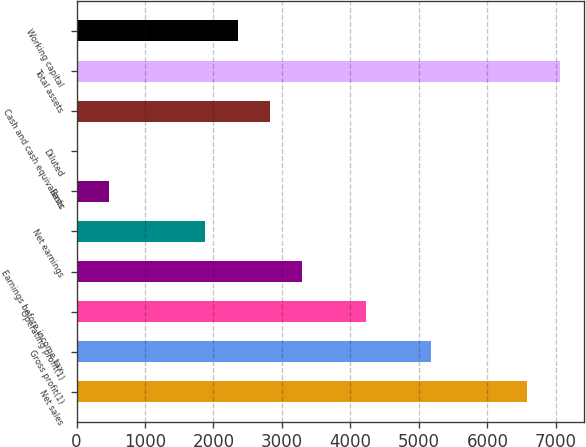Convert chart to OTSL. <chart><loc_0><loc_0><loc_500><loc_500><bar_chart><fcel>Net sales<fcel>Gross profit(1)<fcel>Operating profit(1)<fcel>Earnings before income tax<fcel>Net earnings<fcel>Basic<fcel>Diluted<fcel>Cash and cash equivalents<fcel>Total assets<fcel>Working capital<nl><fcel>6585.33<fcel>5174.4<fcel>4233.78<fcel>3293.16<fcel>1882.23<fcel>471.3<fcel>0.99<fcel>2822.85<fcel>7055.64<fcel>2352.54<nl></chart> 